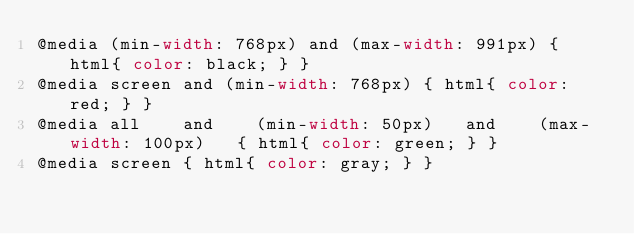Convert code to text. <code><loc_0><loc_0><loc_500><loc_500><_CSS_>@media (min-width: 768px) and (max-width: 991px) { html{ color: black; } }
@media screen and (min-width: 768px) { html{ color: red; } }
@media all    and    (min-width: 50px)   and    (max-width: 100px)   { html{ color: green; } }
@media screen { html{ color: gray; } }</code> 